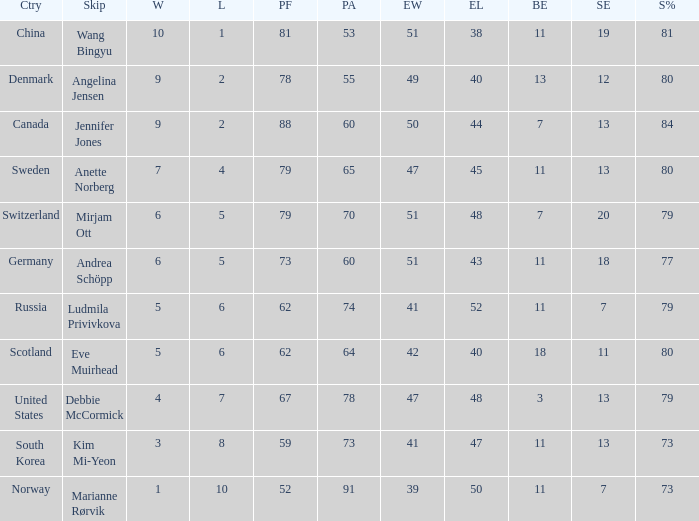Andrea Schöpp is the skip of which country? Germany. 